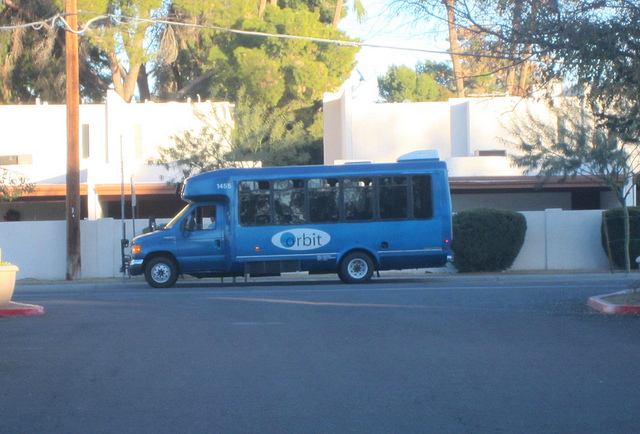Read and extract the text from this image. Orbit 